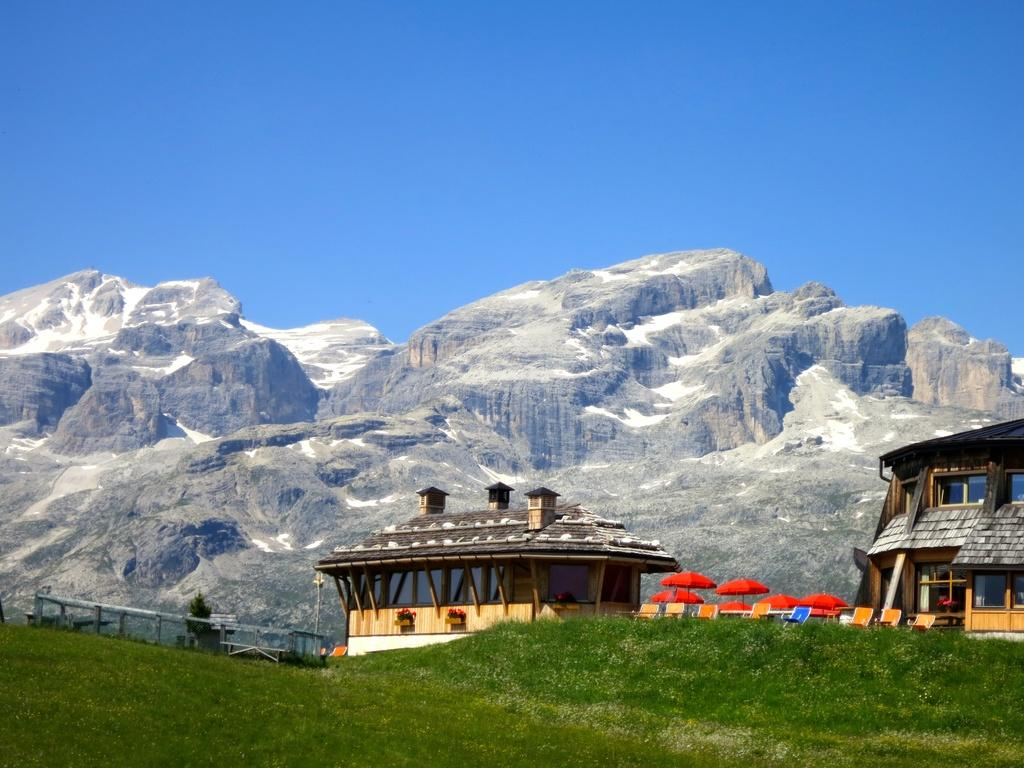What type of structures can be seen in the image? There are houses in the image. What objects are present for protection from the sun or rain? There are umbrellas in the image. What type of furniture is visible in the image? There are chairs in the image. What type of vegetation is present in the image? There is a tree in the image. What type of ground cover is present in the image? There is grass on the ground in the image. What type of geographical feature is present in the image? There is a hill in the image. What color is the sky in the image? The sky is blue in the image. How many leaves are on the plant in the image? There is no plant present in the image, only a tree. What type of fruit is hanging from the banana tree in the image? There is no banana tree present in the image. 